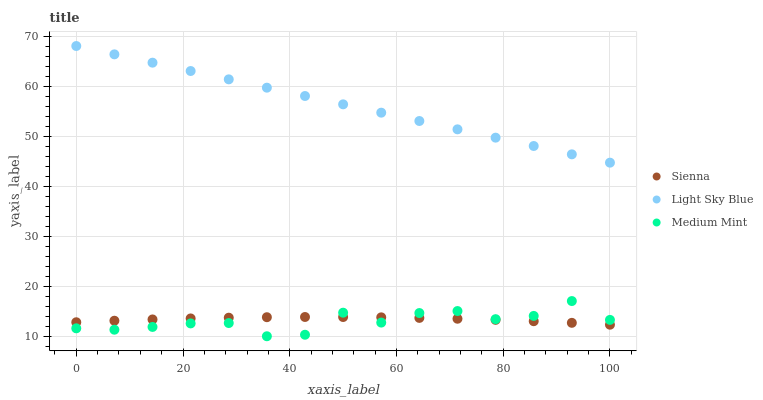Does Medium Mint have the minimum area under the curve?
Answer yes or no. Yes. Does Light Sky Blue have the maximum area under the curve?
Answer yes or no. Yes. Does Light Sky Blue have the minimum area under the curve?
Answer yes or no. No. Does Medium Mint have the maximum area under the curve?
Answer yes or no. No. Is Light Sky Blue the smoothest?
Answer yes or no. Yes. Is Medium Mint the roughest?
Answer yes or no. Yes. Is Medium Mint the smoothest?
Answer yes or no. No. Is Light Sky Blue the roughest?
Answer yes or no. No. Does Medium Mint have the lowest value?
Answer yes or no. Yes. Does Light Sky Blue have the lowest value?
Answer yes or no. No. Does Light Sky Blue have the highest value?
Answer yes or no. Yes. Does Medium Mint have the highest value?
Answer yes or no. No. Is Medium Mint less than Light Sky Blue?
Answer yes or no. Yes. Is Light Sky Blue greater than Medium Mint?
Answer yes or no. Yes. Does Medium Mint intersect Sienna?
Answer yes or no. Yes. Is Medium Mint less than Sienna?
Answer yes or no. No. Is Medium Mint greater than Sienna?
Answer yes or no. No. Does Medium Mint intersect Light Sky Blue?
Answer yes or no. No. 